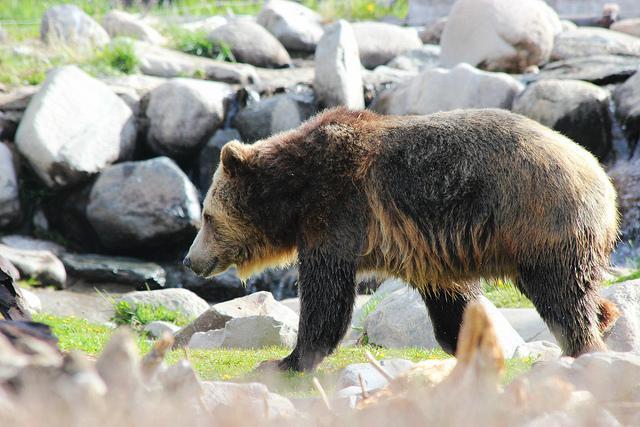How many bears are visible?
Give a very brief answer. 1. 